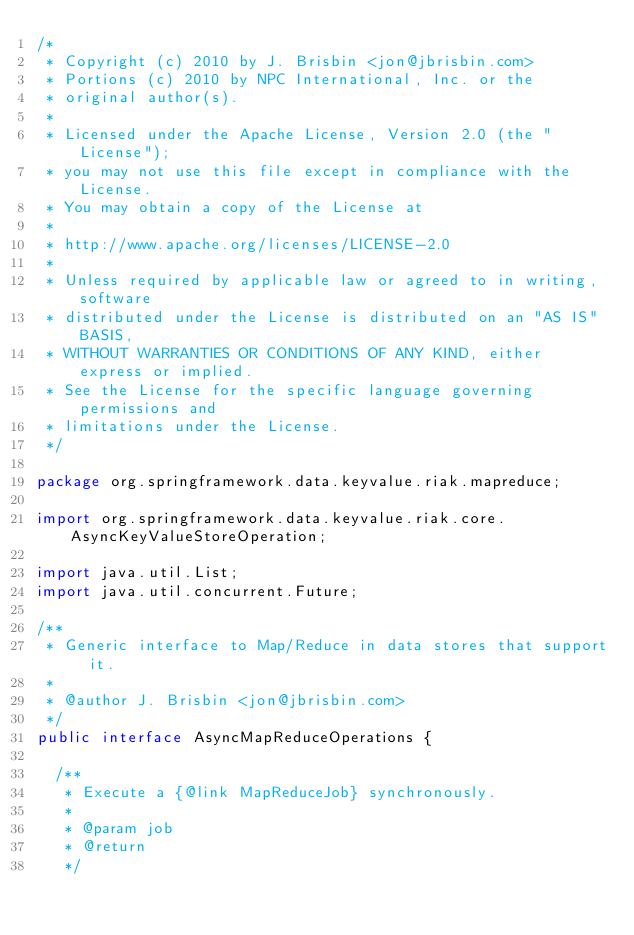<code> <loc_0><loc_0><loc_500><loc_500><_Java_>/*
 * Copyright (c) 2010 by J. Brisbin <jon@jbrisbin.com>
 * Portions (c) 2010 by NPC International, Inc. or the
 * original author(s).
 *
 * Licensed under the Apache License, Version 2.0 (the "License");
 * you may not use this file except in compliance with the License.
 * You may obtain a copy of the License at
 *
 * http://www.apache.org/licenses/LICENSE-2.0
 *
 * Unless required by applicable law or agreed to in writing, software
 * distributed under the License is distributed on an "AS IS" BASIS,
 * WITHOUT WARRANTIES OR CONDITIONS OF ANY KIND, either express or implied.
 * See the License for the specific language governing permissions and
 * limitations under the License.
 */

package org.springframework.data.keyvalue.riak.mapreduce;

import org.springframework.data.keyvalue.riak.core.AsyncKeyValueStoreOperation;

import java.util.List;
import java.util.concurrent.Future;

/**
 * Generic interface to Map/Reduce in data stores that support it.
 *
 * @author J. Brisbin <jon@jbrisbin.com>
 */
public interface AsyncMapReduceOperations {

  /**
   * Execute a {@link MapReduceJob} synchronously.
   *
   * @param job
   * @return
   */</code> 